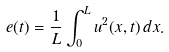Convert formula to latex. <formula><loc_0><loc_0><loc_500><loc_500>e ( t ) = \frac { 1 } { L } \int _ { 0 } ^ { L } u ^ { 2 } ( x , t ) \, d x .</formula> 